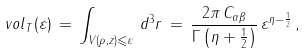Convert formula to latex. <formula><loc_0><loc_0><loc_500><loc_500>\ v o l _ { T } ( \varepsilon ) \, = \, \int _ { V ( \rho , z ) \leqslant \varepsilon } \, d ^ { 3 } r \, = \, \frac { 2 \pi \, C _ { \alpha \beta } } { \Gamma \left ( \eta + \frac { 1 } { 2 } \right ) } \, \varepsilon ^ { \eta - \frac { 1 } { 2 } } \, ,</formula> 